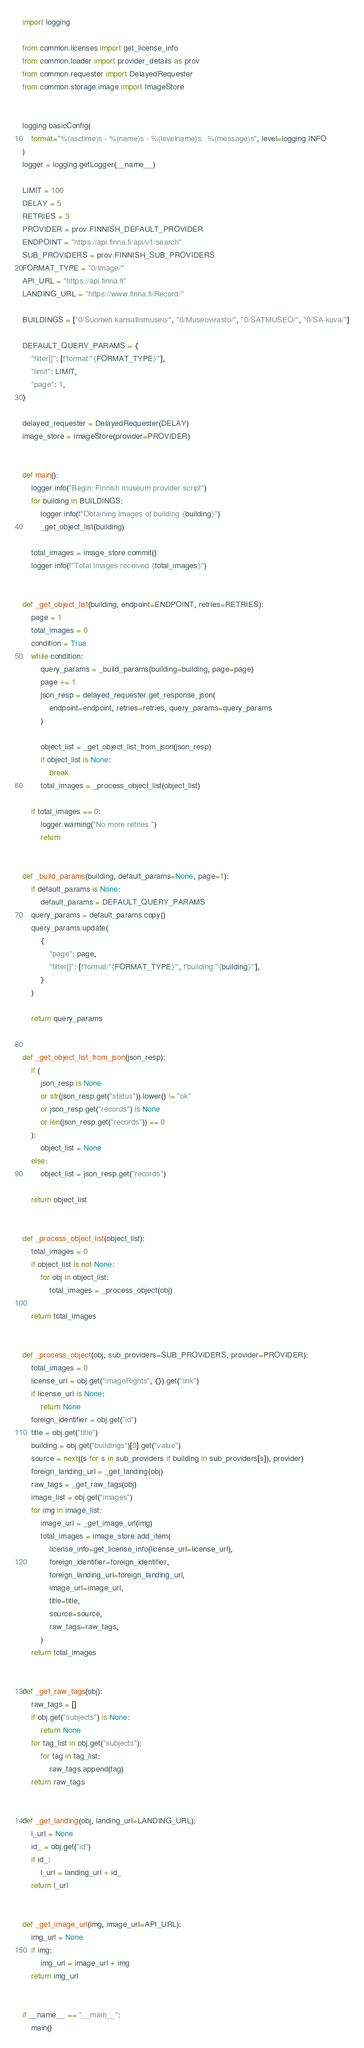<code> <loc_0><loc_0><loc_500><loc_500><_Python_>import logging

from common.licenses import get_license_info
from common.loader import provider_details as prov
from common.requester import DelayedRequester
from common.storage.image import ImageStore


logging.basicConfig(
    format="%(asctime)s - %(name)s - %(levelname)s:  %(message)s", level=logging.INFO
)
logger = logging.getLogger(__name__)

LIMIT = 100
DELAY = 5
RETRIES = 3
PROVIDER = prov.FINNISH_DEFAULT_PROVIDER
ENDPOINT = "https://api.finna.fi/api/v1/search"
SUB_PROVIDERS = prov.FINNISH_SUB_PROVIDERS
FORMAT_TYPE = "0/Image/"
API_URL = "https://api.finna.fi"
LANDING_URL = "https://www.finna.fi/Record/"

BUILDINGS = ["0/Suomen kansallismuseo/", "0/Museovirasto/", "0/SATMUSEO/", "0/SA-kuva/"]

DEFAULT_QUERY_PARAMS = {
    "filter[]": [f'format:"{FORMAT_TYPE}"'],
    "limit": LIMIT,
    "page": 1,
}

delayed_requester = DelayedRequester(DELAY)
image_store = ImageStore(provider=PROVIDER)


def main():
    logger.info("Begin: Finnish museum provider script")
    for building in BUILDINGS:
        logger.info(f"Obtaining Images of building {building}")
        _get_object_list(building)

    total_images = image_store.commit()
    logger.info(f"Total Images received {total_images}")


def _get_object_list(building, endpoint=ENDPOINT, retries=RETRIES):
    page = 1
    total_images = 0
    condition = True
    while condition:
        query_params = _build_params(building=building, page=page)
        page += 1
        json_resp = delayed_requester.get_response_json(
            endpoint=endpoint, retries=retries, query_params=query_params
        )

        object_list = _get_object_list_from_json(json_resp)
        if object_list is None:
            break
        total_images = _process_object_list(object_list)

    if total_images == 0:
        logger.warning("No more retries ")
        return


def _build_params(building, default_params=None, page=1):
    if default_params is None:
        default_params = DEFAULT_QUERY_PARAMS
    query_params = default_params.copy()
    query_params.update(
        {
            "page": page,
            "filter[]": [f'format:"{FORMAT_TYPE}"', f'building:"{building}"'],
        }
    )

    return query_params


def _get_object_list_from_json(json_resp):
    if (
        json_resp is None
        or str(json_resp.get("status")).lower() != "ok"
        or json_resp.get("records") is None
        or len(json_resp.get("records")) == 0
    ):
        object_list = None
    else:
        object_list = json_resp.get("records")

    return object_list


def _process_object_list(object_list):
    total_images = 0
    if object_list is not None:
        for obj in object_list:
            total_images = _process_object(obj)

    return total_images


def _process_object(obj, sub_providers=SUB_PROVIDERS, provider=PROVIDER):
    total_images = 0
    license_url = obj.get("imageRights", {}).get("link")
    if license_url is None:
        return None
    foreign_identifier = obj.get("id")
    title = obj.get("title")
    building = obj.get("buildings")[0].get("value")
    source = next((s for s in sub_providers if building in sub_providers[s]), provider)
    foreign_landing_url = _get_landing(obj)
    raw_tags = _get_raw_tags(obj)
    image_list = obj.get("images")
    for img in image_list:
        image_url = _get_image_url(img)
        total_images = image_store.add_item(
            license_info=get_license_info(license_url=license_url),
            foreign_identifier=foreign_identifier,
            foreign_landing_url=foreign_landing_url,
            image_url=image_url,
            title=title,
            source=source,
            raw_tags=raw_tags,
        )
    return total_images


def _get_raw_tags(obj):
    raw_tags = []
    if obj.get("subjects") is None:
        return None
    for tag_list in obj.get("subjects"):
        for tag in tag_list:
            raw_tags.append(tag)
    return raw_tags


def _get_landing(obj, landing_url=LANDING_URL):
    l_url = None
    id_ = obj.get("id")
    if id_:
        l_url = landing_url + id_
    return l_url


def _get_image_url(img, image_url=API_URL):
    img_url = None
    if img:
        img_url = image_url + img
    return img_url


if __name__ == "__main__":
    main()
</code> 